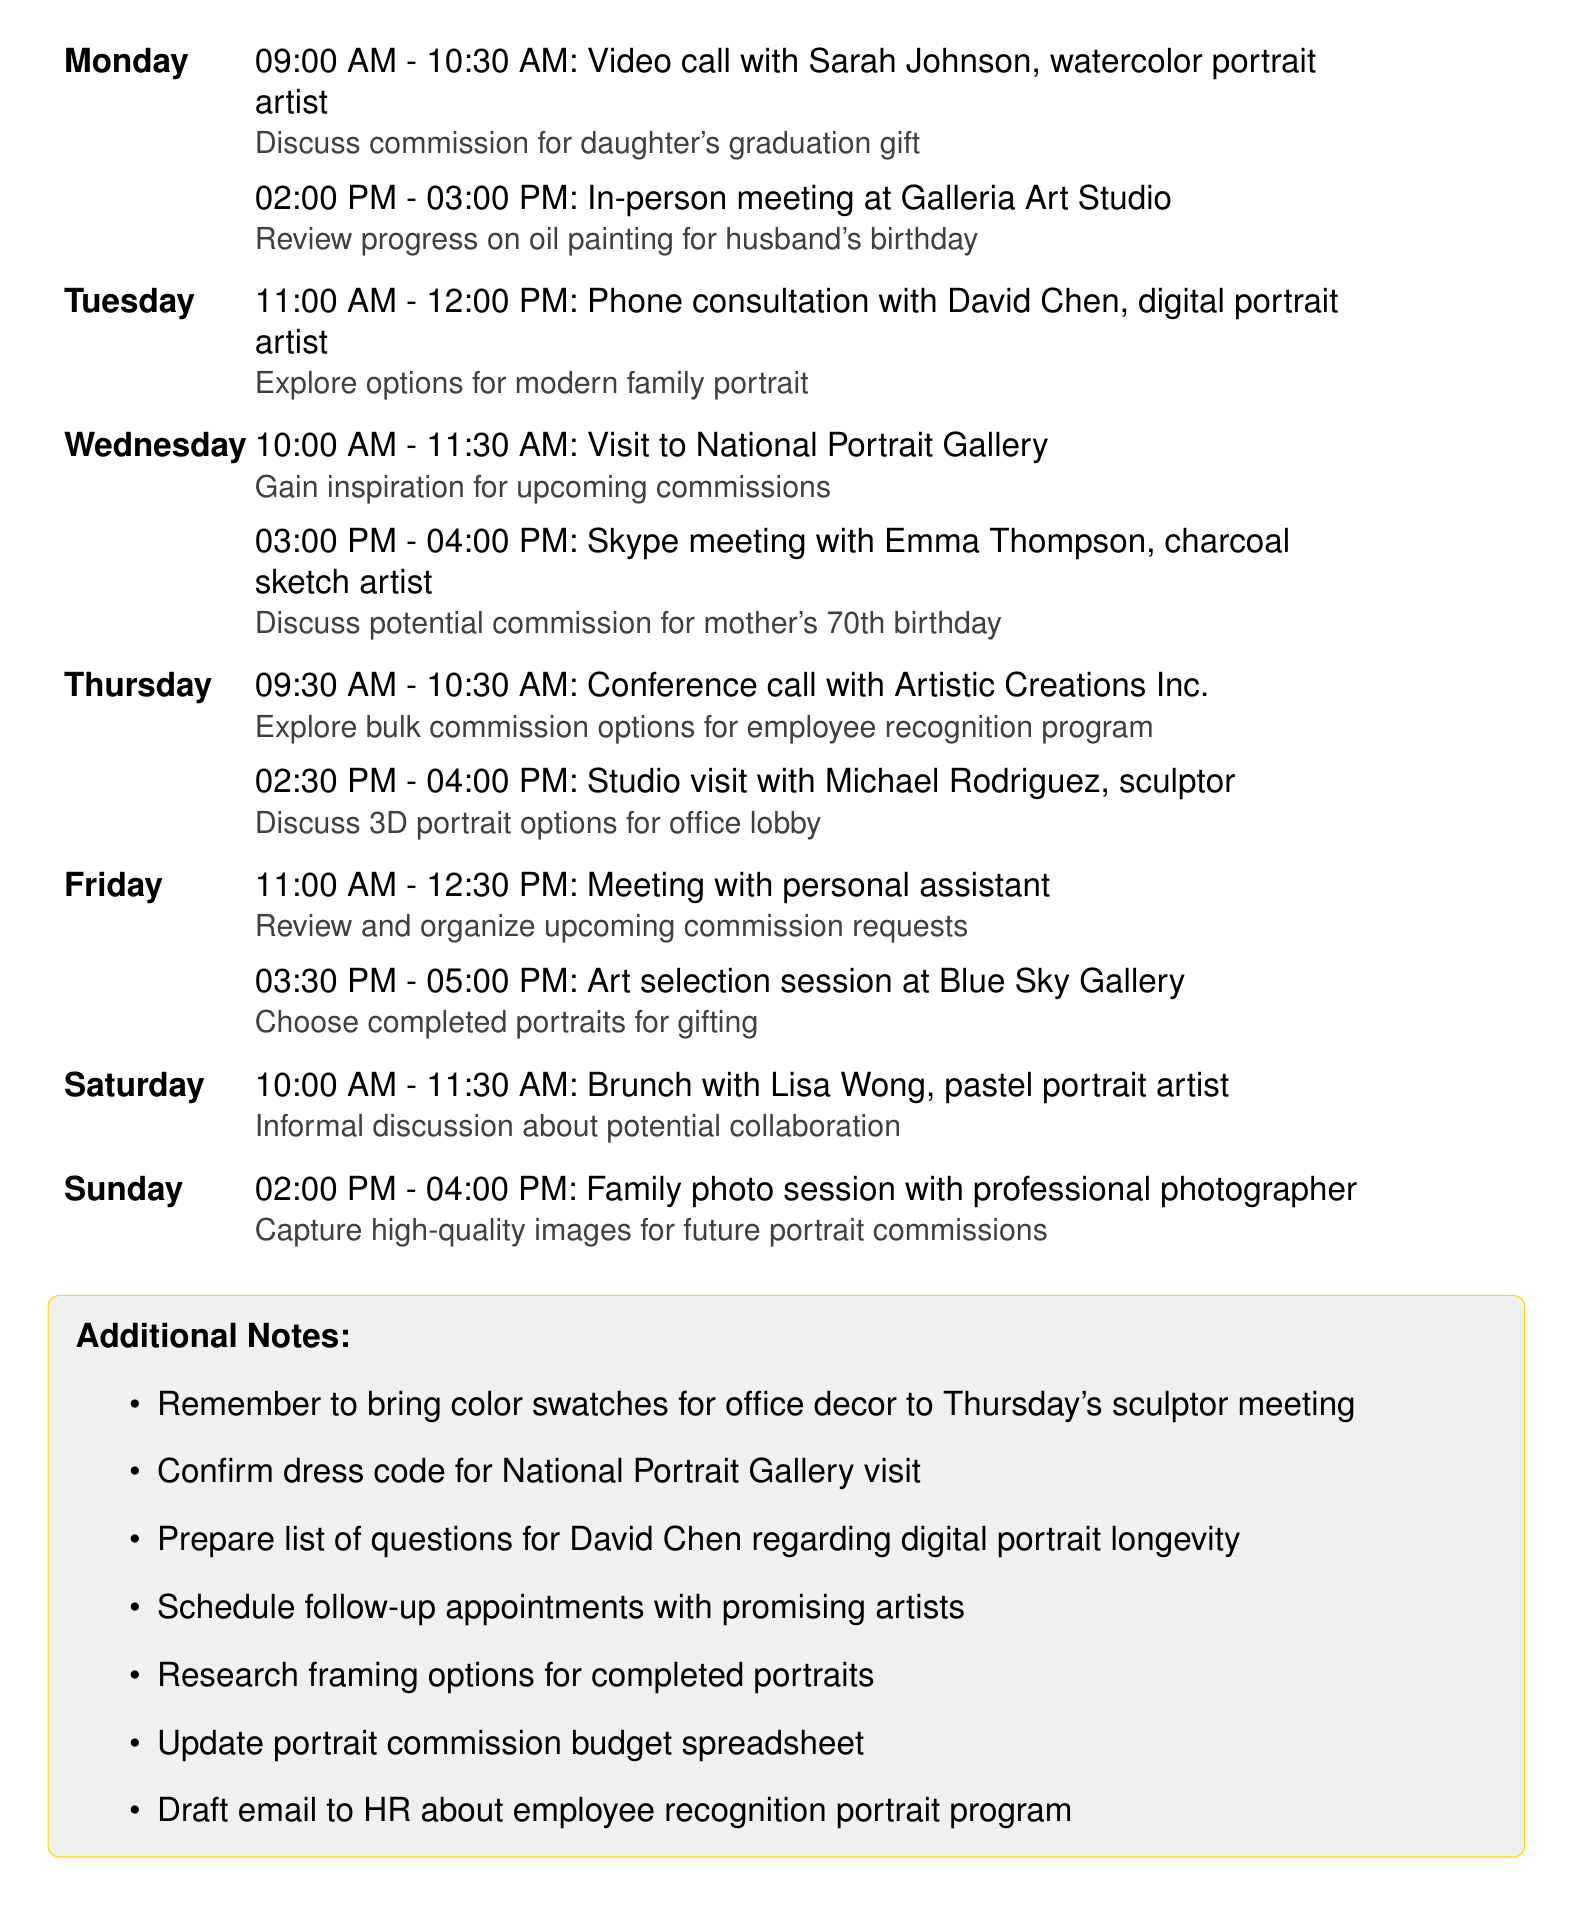What time is the video call with Sarah Johnson? The video call is scheduled for 09:00 AM to 10:30 AM on Monday.
Answer: 09:00 AM - 10:30 AM Who is the artist for the family's modern portrait consultation? The consultation will be with David Chen, a digital portrait artist.
Answer: David Chen When is the family photo session scheduled? The family photo session is set for 02:00 PM to 04:00 PM on Sunday.
Answer: 02:00 PM - 04:00 PM Which day has a meeting with Lisa Wong? The brunch meeting with Lisa Wong is scheduled for Saturday.
Answer: Saturday What is the main focus of Thursday's conference call? The main focus is to explore bulk commission options for an employee recognition program.
Answer: Bulk commission options How many portrait commissions are mentioned for upcoming meetings this week? There are eight distinct commission discussions scheduled throughout the week.
Answer: Eight What type of meeting is scheduled with Michael Rodriguez? The meeting with Michael Rodriguez will take place at his studio, focusing on discussing 3D portrait options.
Answer: Studio visit What additional note addresses the National Portrait Gallery visit? The additional note reminds to confirm the dress code for the visit.
Answer: Confirm dress code What is the purpose of the session at Blue Sky Gallery on Friday? The session at Blue Sky Gallery is for choosing completed portraits for gifting.
Answer: Choose completed portraits 